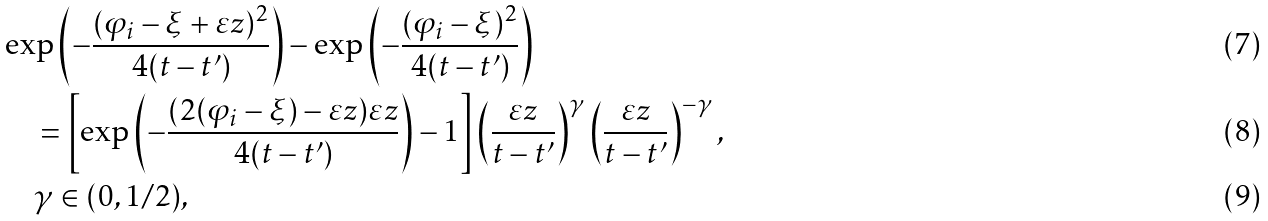<formula> <loc_0><loc_0><loc_500><loc_500>& \exp \left ( - \frac { ( \varphi _ { i } - \xi + \varepsilon z ) ^ { 2 } } { 4 ( t - t ^ { \prime } ) } \right ) - \exp \left ( - \frac { ( \varphi _ { i } - \xi ) ^ { 2 } } { 4 ( t - t ^ { \prime } ) } \right ) \\ & \quad = \left [ \exp \left ( - \frac { ( 2 ( \varphi _ { i } - \xi ) - \varepsilon z ) \varepsilon z } { 4 ( t - t ^ { \prime } ) } \right ) - 1 \right ] \left ( \frac { \varepsilon z } { t - t ^ { \prime } } \right ) ^ { \gamma } \left ( \frac { \varepsilon z } { t - t ^ { \prime } } \right ) ^ { - \gamma } , \\ & \quad \gamma \in ( 0 , 1 / 2 ) ,</formula> 